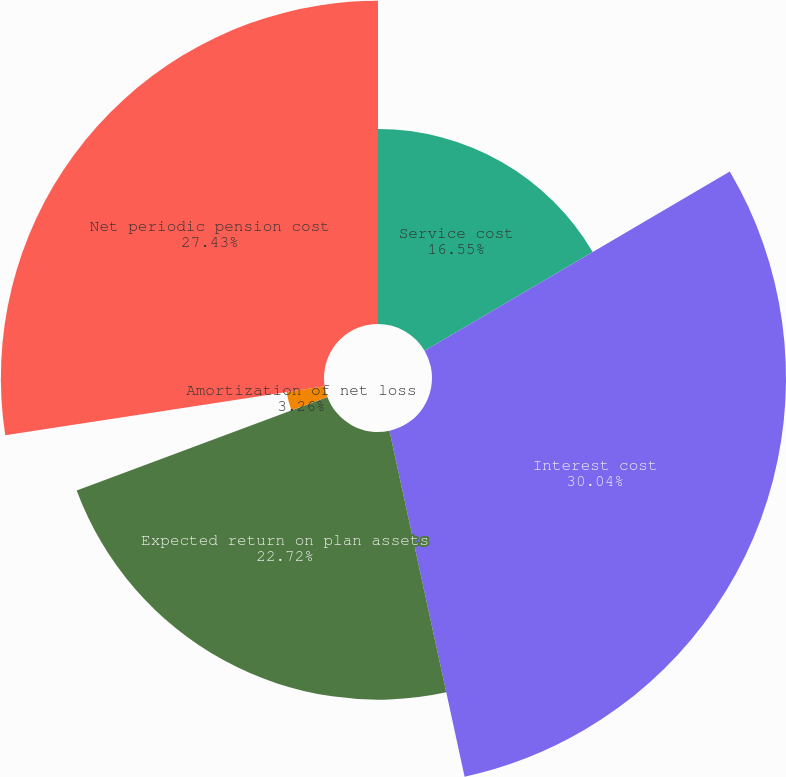Convert chart to OTSL. <chart><loc_0><loc_0><loc_500><loc_500><pie_chart><fcel>Service cost<fcel>Interest cost<fcel>Expected return on plan assets<fcel>Amortization of net loss<fcel>Net periodic pension cost<nl><fcel>16.55%<fcel>30.05%<fcel>22.72%<fcel>3.26%<fcel>27.43%<nl></chart> 